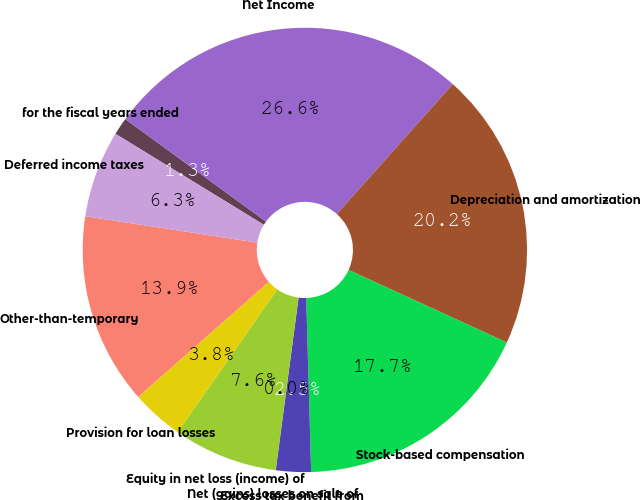Convert chart to OTSL. <chart><loc_0><loc_0><loc_500><loc_500><pie_chart><fcel>for the fiscal years ended<fcel>Net Income<fcel>Depreciation and amortization<fcel>Stock-based compensation<fcel>Excess tax benefit from<fcel>Net (gains) losses on sale of<fcel>Equity in net loss (income) of<fcel>Provision for loan losses<fcel>Other-than-temporary<fcel>Deferred income taxes<nl><fcel>1.27%<fcel>26.57%<fcel>20.24%<fcel>17.71%<fcel>2.54%<fcel>0.01%<fcel>7.6%<fcel>3.8%<fcel>13.92%<fcel>6.33%<nl></chart> 